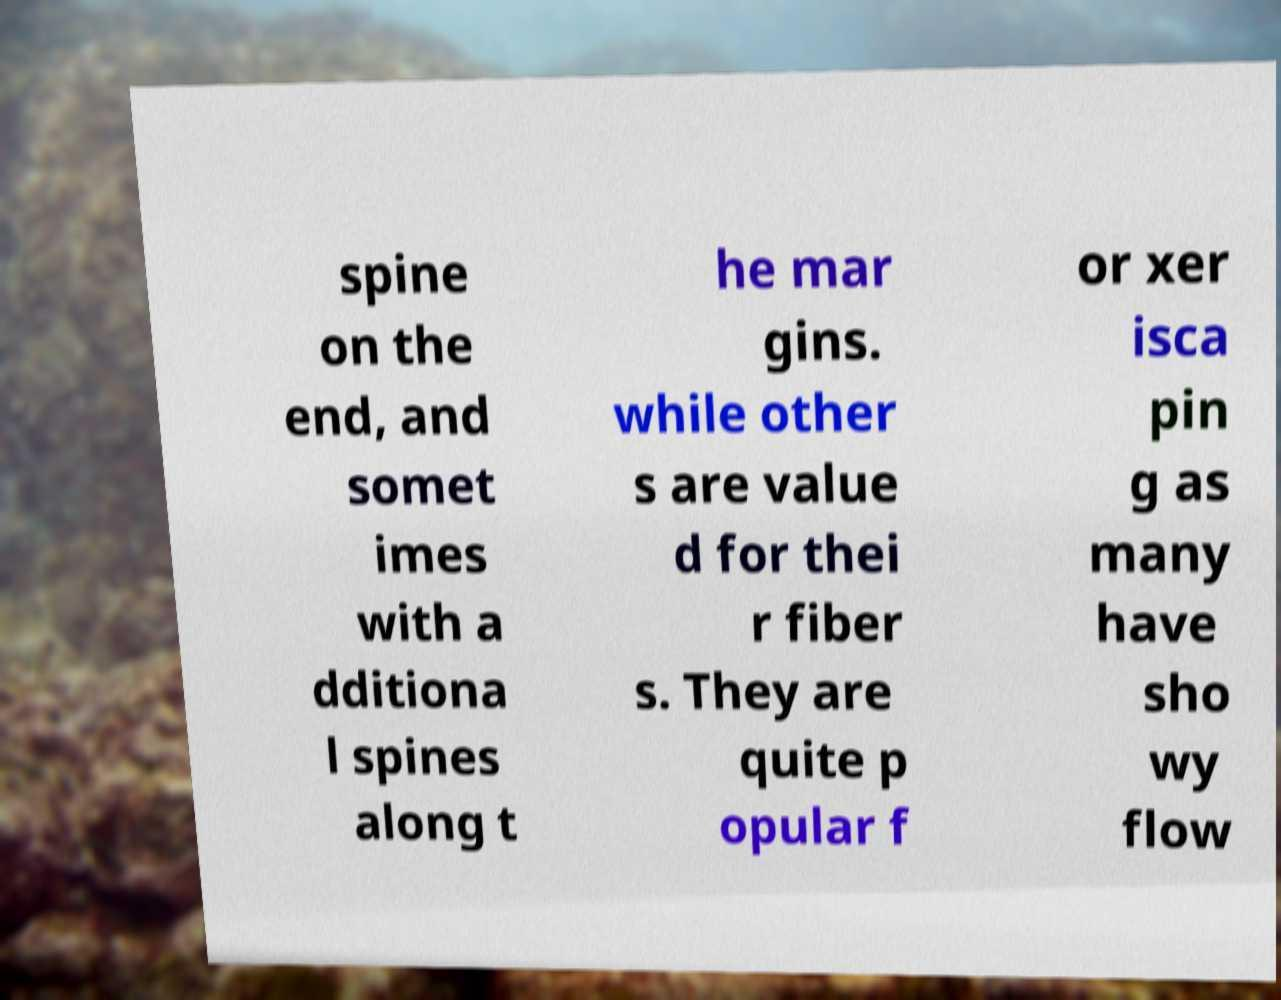For documentation purposes, I need the text within this image transcribed. Could you provide that? spine on the end, and somet imes with a dditiona l spines along t he mar gins. while other s are value d for thei r fiber s. They are quite p opular f or xer isca pin g as many have sho wy flow 